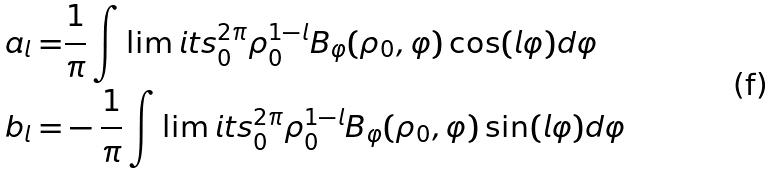Convert formula to latex. <formula><loc_0><loc_0><loc_500><loc_500>a _ { l } = & \frac { 1 } { \pi } \int \lim i t s _ { 0 } ^ { 2 \pi } \rho _ { 0 } ^ { 1 - l } B _ { \varphi } ( \rho _ { 0 } , \varphi ) \cos ( l \varphi ) d { \varphi } \\ b _ { l } = & - \frac { 1 } { \pi } \int \lim i t s _ { 0 } ^ { 2 \pi } \rho _ { 0 } ^ { 1 - l } B _ { \varphi } ( \rho _ { 0 } , \varphi ) \sin ( l \varphi ) d { \varphi }</formula> 